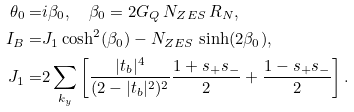Convert formula to latex. <formula><loc_0><loc_0><loc_500><loc_500>\theta _ { 0 } = & i \beta _ { 0 } , \quad \beta _ { 0 } = 2 G _ { Q } \, N _ { Z E S } \, R _ { N } , \\ I _ { B } = & J _ { 1 } \cosh ^ { 2 } ( \beta _ { 0 } ) - N _ { Z E S } \, \sinh ( 2 \beta _ { 0 } ) , \\ J _ { 1 } = & 2 \sum _ { k _ { y } } \left [ \frac { | t _ { b } | ^ { 4 } } { ( 2 - | t _ { b } | ^ { 2 } ) ^ { 2 } } \frac { 1 + s _ { + } s _ { - } } { 2 } + \frac { 1 - s _ { + } s _ { - } } { 2 } \right ] .</formula> 